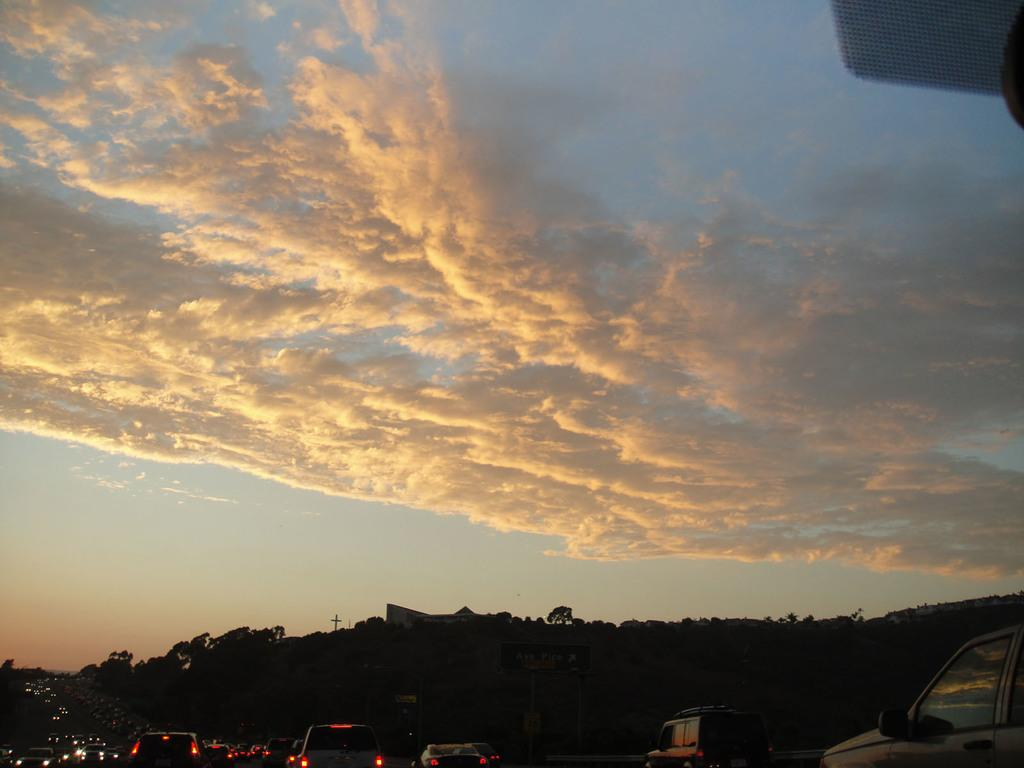What can be seen in the sky in the image? The sky with clouds is visible in the image. What type of structures are present in the image? There are buildings in the image. What type of vegetation is present in the image? Trees are present in the image. What type of transportation is on the road in the image? Motor vehicles are on the road in the image. What type of pear is hanging from the tree in the image? There is no pear present in the image; it features a sky with clouds, buildings, trees, and motor vehicles. What type of quartz can be seen in the image? There is no quartz present in the image. 